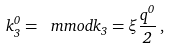<formula> <loc_0><loc_0><loc_500><loc_500>k _ { 3 } ^ { 0 } = \ m m o d { k } _ { 3 } = \xi \frac { q ^ { 0 } } { 2 } \, ,</formula> 